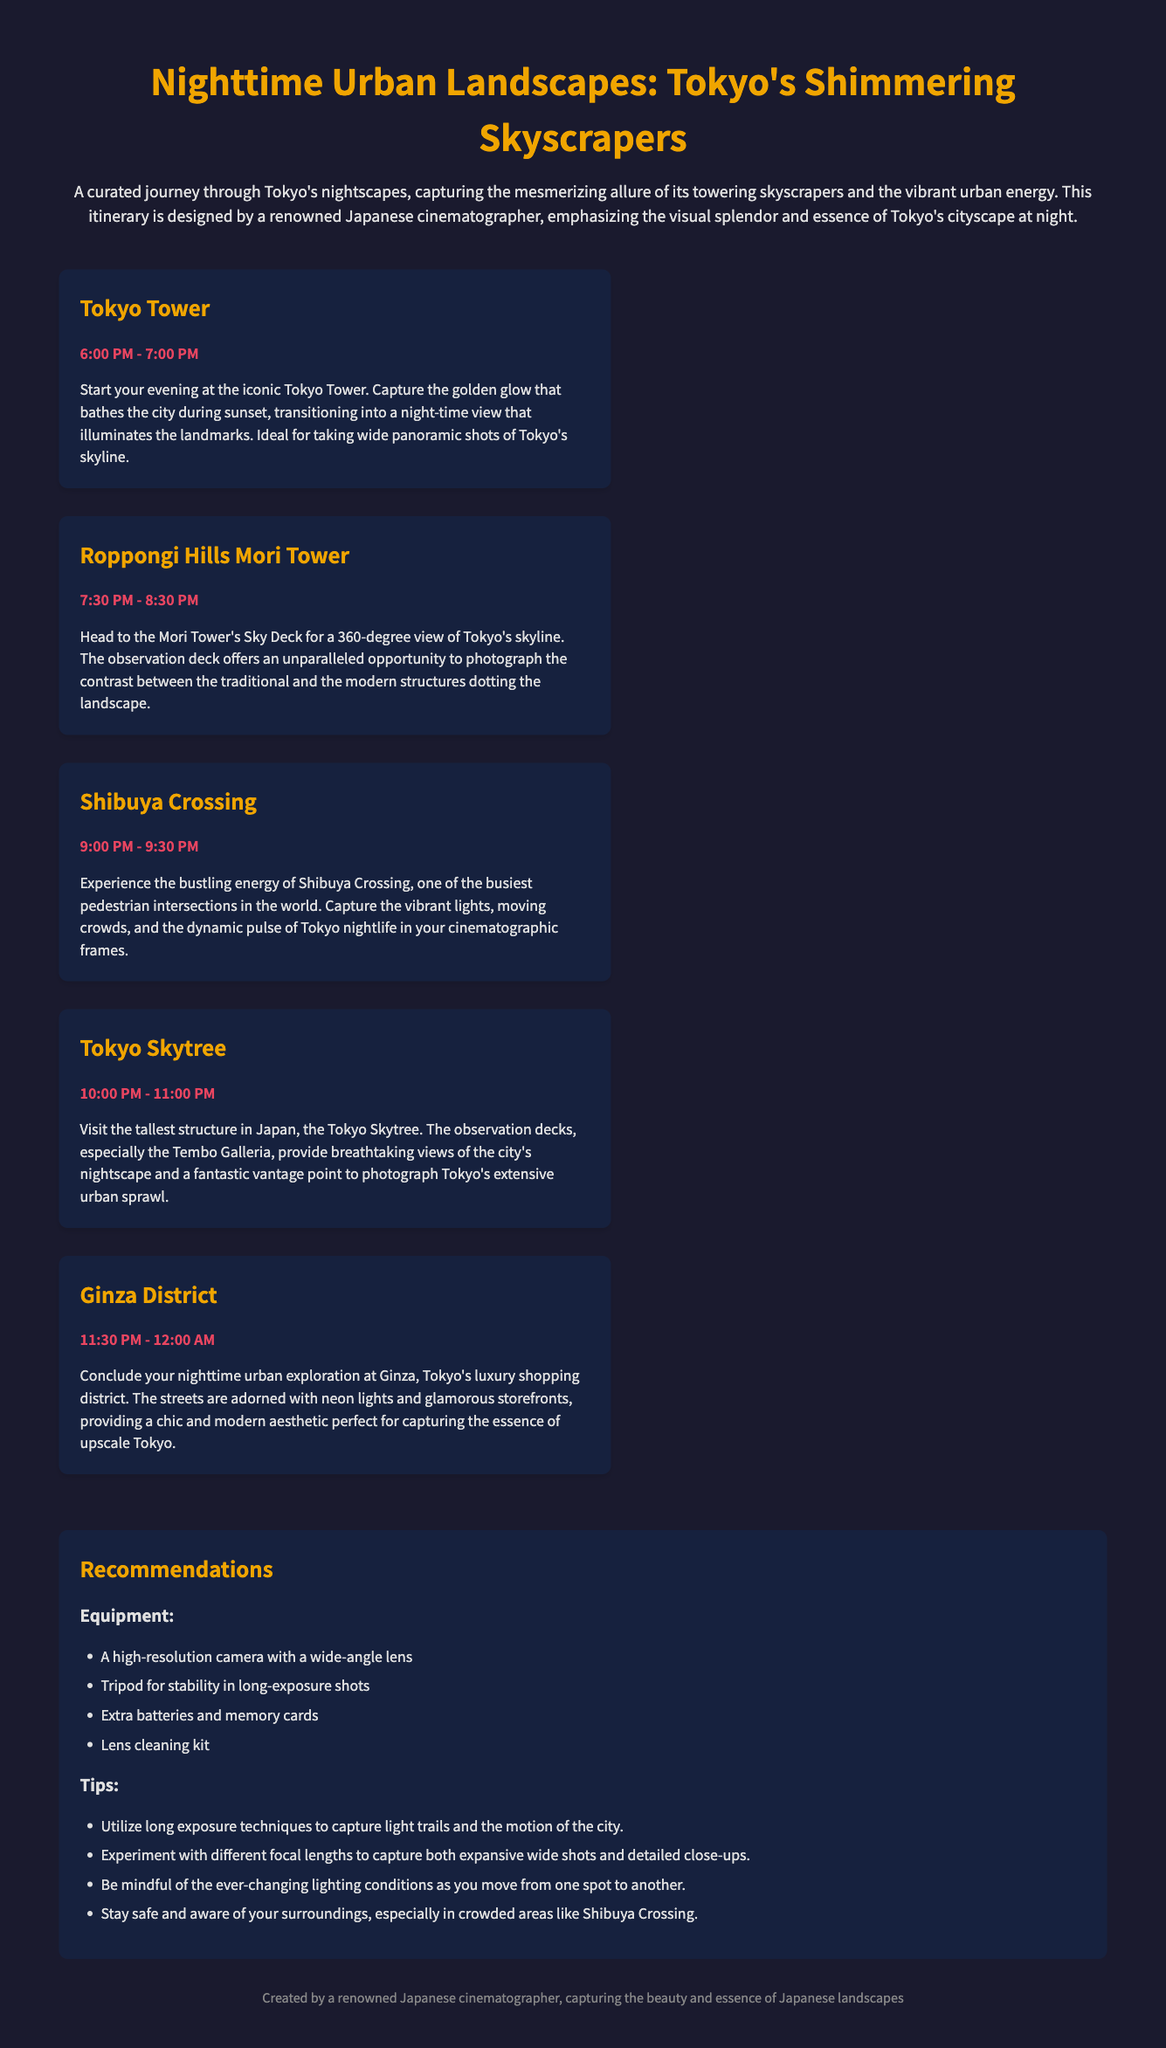What is the first stop in the itinerary? The first stop in the itinerary is listed as Tokyo Tower.
Answer: Tokyo Tower What time does the visit to Roppongi Hills Mori Tower start? The visit to Roppongi Hills Mori Tower starts at 7:30 PM.
Answer: 7:30 PM How long is the stay at Shibuya Crossing? The stay at Shibuya Crossing is for 30 minutes, from 9:00 PM to 9:30 PM.
Answer: 30 minutes What is the last stop of the itinerary? The last stop of the itinerary is Ginza District.
Answer: Ginza District What type of camera is recommended? A high-resolution camera with a wide-angle lens is recommended for the journey.
Answer: High-resolution camera with a wide-angle lens Why is the Mori Tower's Sky Deck notable? The Mori Tower's Sky Deck is notable for offering a 360-degree view of Tokyo's skyline.
Answer: 360-degree view What safety advice is given for crowded areas? The document advises to stay safe and aware of your surroundings, especially in crowded areas like Shibuya Crossing.
Answer: Stay safe and aware How many total stops are there in the itinerary? The document lists a total of five stops in the itinerary.
Answer: Five stops What visual theme does the document emphasize? The document emphasizes capturing the mesmerizing allure of Tokyo's towering skyscrapers at night.
Answer: Mesmerizing allure of Tokyo's towering skyscrapers at night 